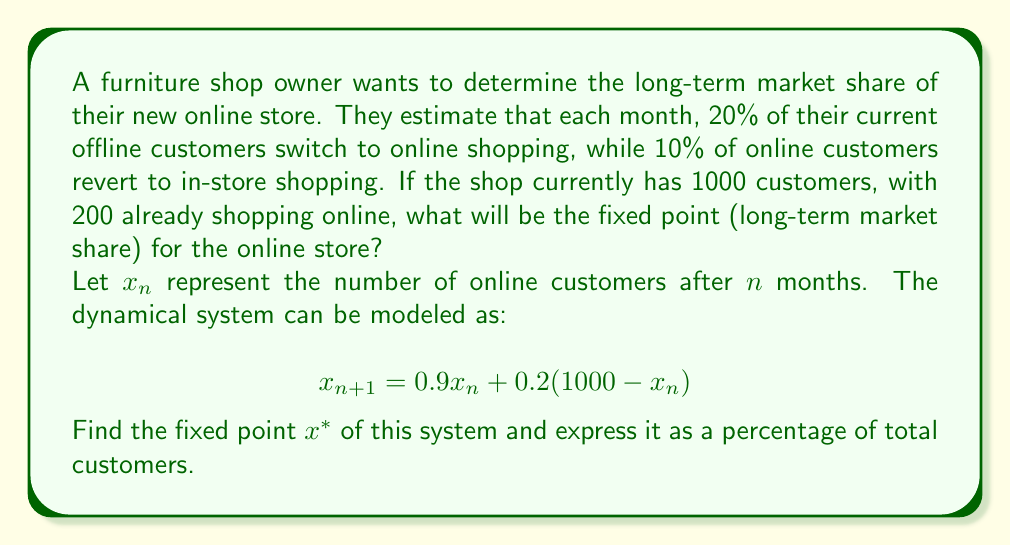Could you help me with this problem? To solve this problem, we'll follow these steps:

1) First, we need to find the fixed point of the system. A fixed point $x^*$ satisfies the equation $x^* = f(x^*)$, where $f$ is our function.

2) In this case, our function is:
   $$f(x) = 0.9x + 0.2(1000 - x) = 0.9x + 200 - 0.2x = 0.7x + 200$$

3) Setting up the fixed point equation:
   $$x^* = 0.7x^* + 200$$

4) Solving for $x^*$:
   $$x^* - 0.7x^* = 200$$
   $$0.3x^* = 200$$
   $$x^* = \frac{200}{0.3} \approx 666.67$$

5) To express this as a percentage of total customers:
   $$\text{Percentage} = \frac{x^*}{1000} \times 100\% = \frac{666.67}{1000} \times 100\% \approx 66.67\%$$

Therefore, in the long term, approximately 66.67% of the furniture shop's customers will be shopping online.
Answer: 66.67% 